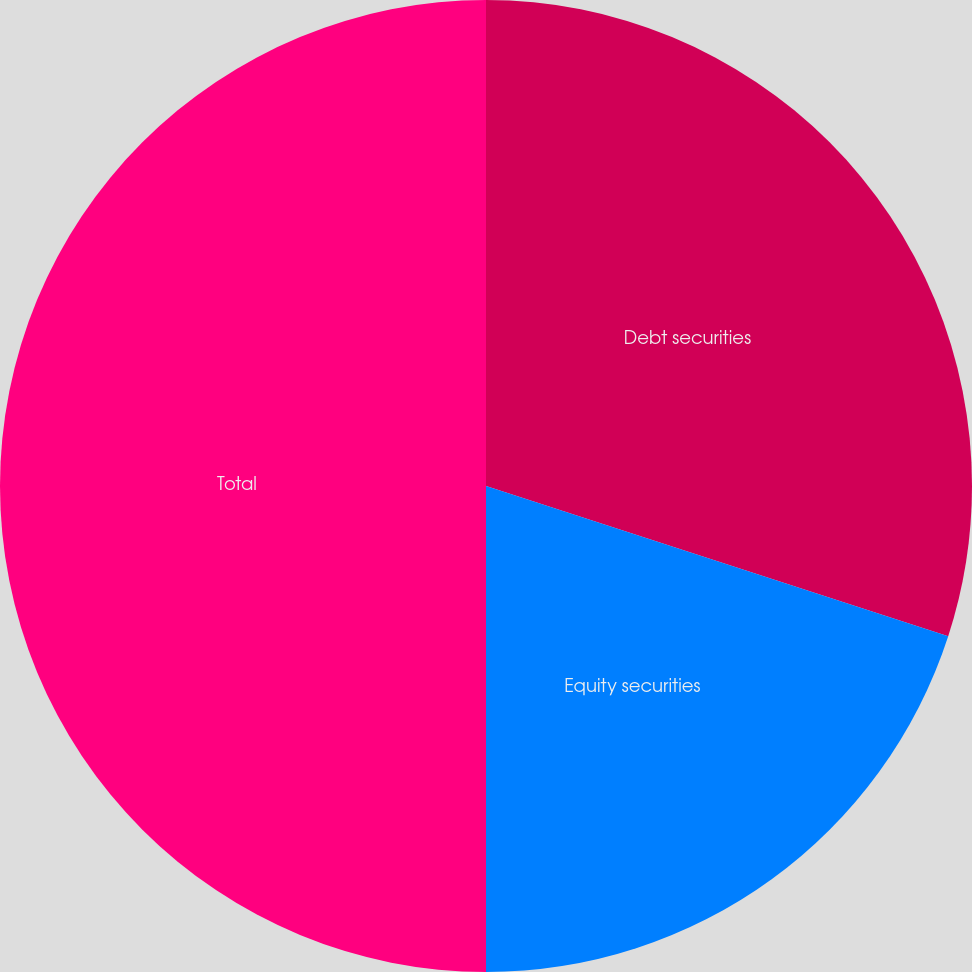Convert chart to OTSL. <chart><loc_0><loc_0><loc_500><loc_500><pie_chart><fcel>Debt securities<fcel>Equity securities<fcel>Total<nl><fcel>30.0%<fcel>20.0%<fcel>50.0%<nl></chart> 